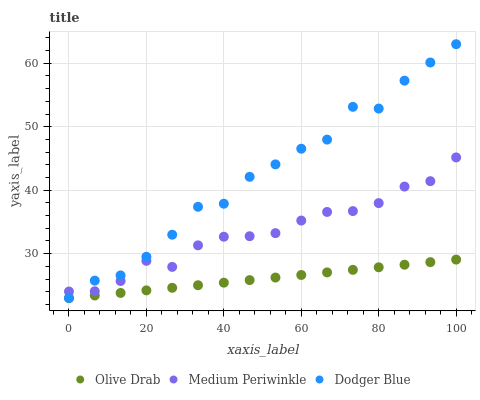Does Olive Drab have the minimum area under the curve?
Answer yes or no. Yes. Does Dodger Blue have the maximum area under the curve?
Answer yes or no. Yes. Does Medium Periwinkle have the minimum area under the curve?
Answer yes or no. No. Does Medium Periwinkle have the maximum area under the curve?
Answer yes or no. No. Is Olive Drab the smoothest?
Answer yes or no. Yes. Is Dodger Blue the roughest?
Answer yes or no. Yes. Is Medium Periwinkle the smoothest?
Answer yes or no. No. Is Medium Periwinkle the roughest?
Answer yes or no. No. Does Dodger Blue have the lowest value?
Answer yes or no. Yes. Does Medium Periwinkle have the lowest value?
Answer yes or no. No. Does Dodger Blue have the highest value?
Answer yes or no. Yes. Does Medium Periwinkle have the highest value?
Answer yes or no. No. Is Olive Drab less than Medium Periwinkle?
Answer yes or no. Yes. Is Medium Periwinkle greater than Olive Drab?
Answer yes or no. Yes. Does Dodger Blue intersect Olive Drab?
Answer yes or no. Yes. Is Dodger Blue less than Olive Drab?
Answer yes or no. No. Is Dodger Blue greater than Olive Drab?
Answer yes or no. No. Does Olive Drab intersect Medium Periwinkle?
Answer yes or no. No. 